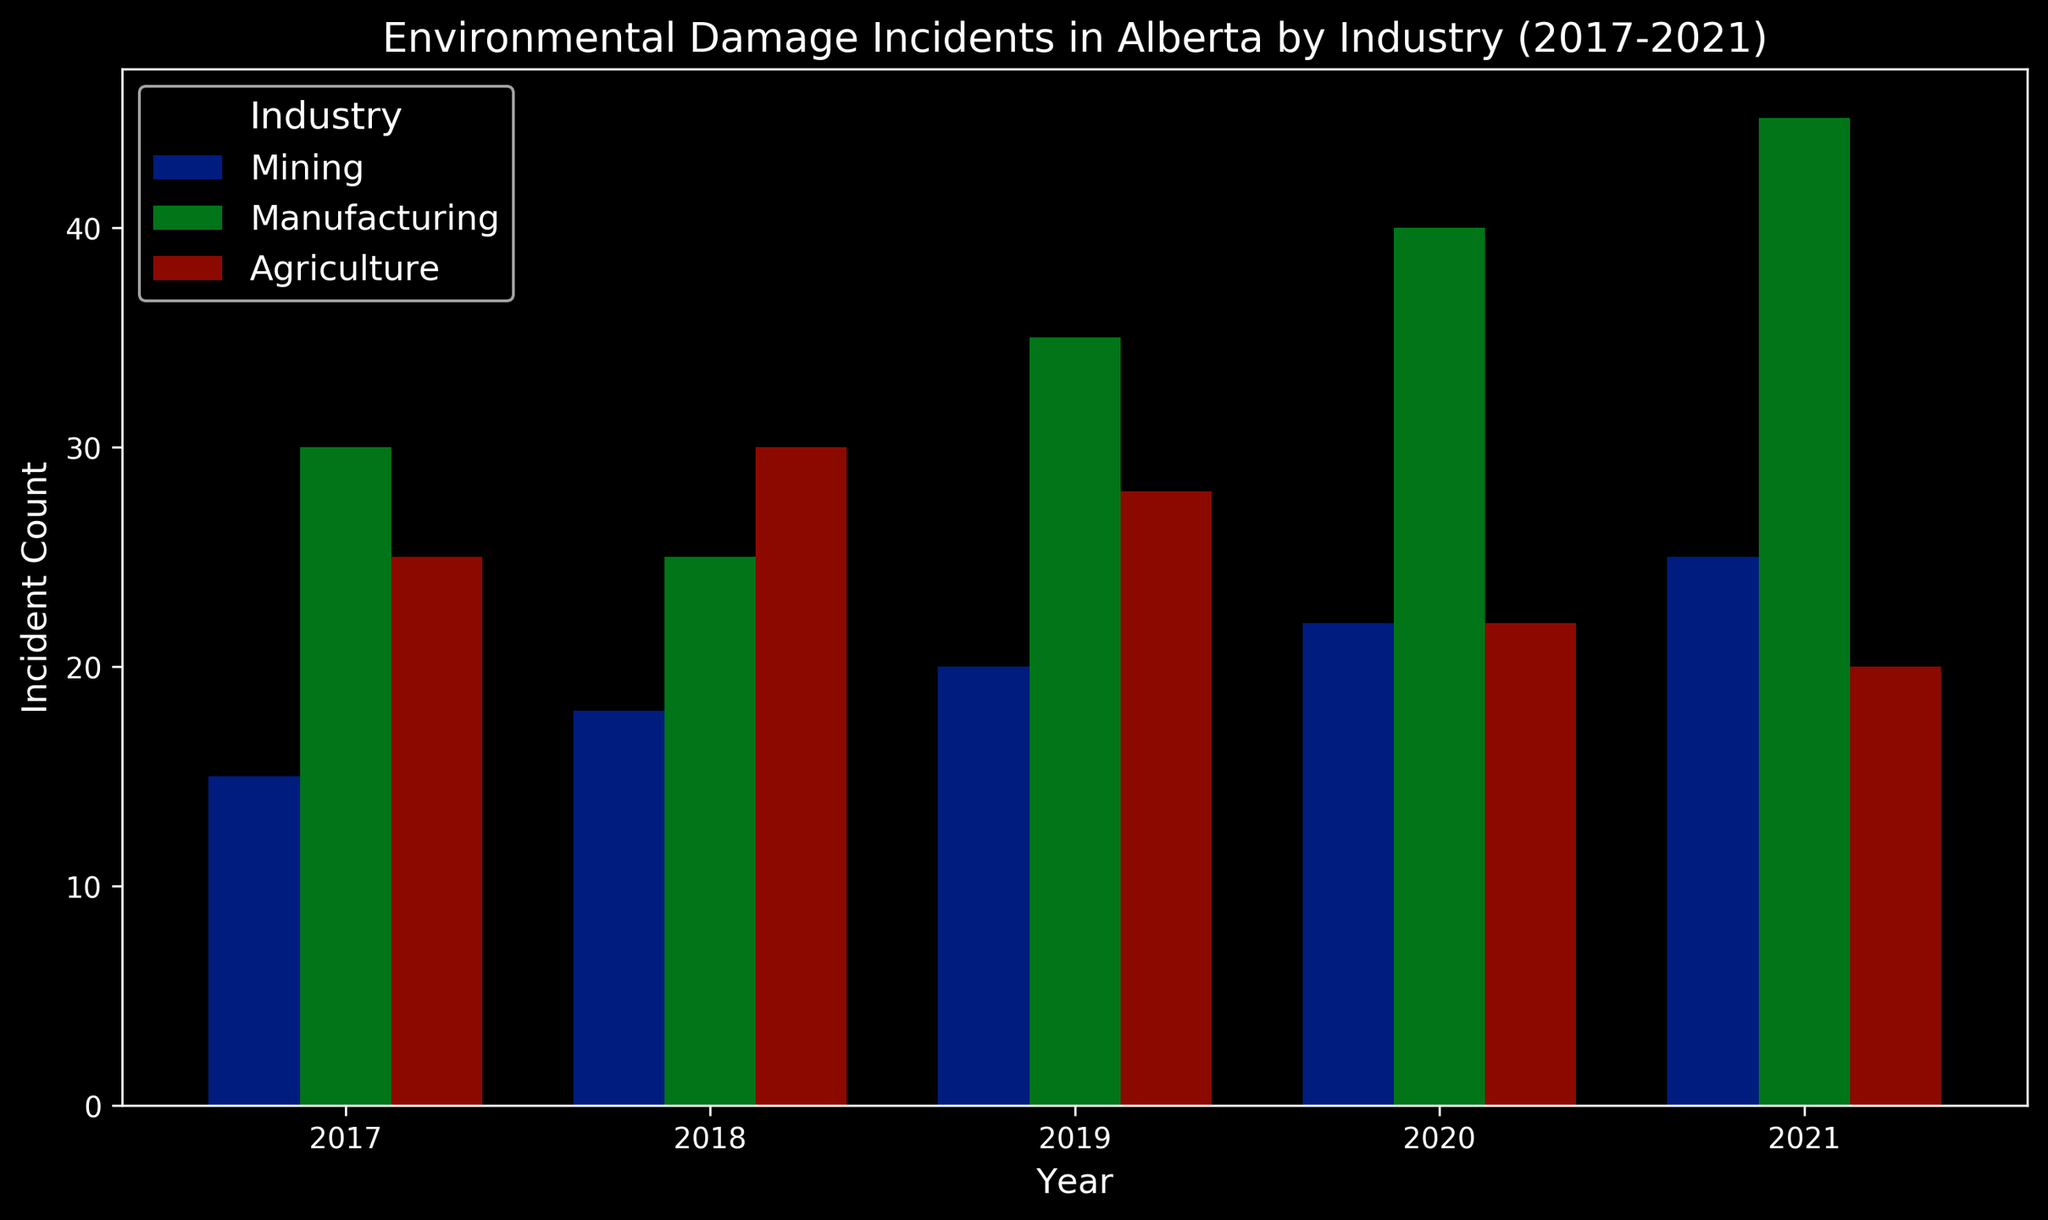What was the total number of environmental incidents in 2019? Sum up the incidents from mining, manufacturing, and agriculture in 2019: 20 (mining) + 35 (manufacturing) + 28 (agriculture) = 83
Answer: 83 Which industry had the highest number of incidents in 2020? Compare the incident counts for each industry in 2020: Mining (22), Manufacturing (40), and Agriculture (22). The highest is Manufacturing with 40 incidents
Answer: Manufacturing How did the number of incidents in agriculture change from 2017 to 2021? Compare the incidents in agriculture in 2017 (25) and 2021 (20): 25 - 20 = 5. The number decreased by 5
Answer: Decreased by 5 In which year did manufacturing incidents increase the most compared to the previous year? Calculate the increase in each year: 2018-2017 (25-30 = -5), 2019-2018 (35-25 = 10), 2020-2019 (40-35 = 5), 2021-2020 (45-40 = 5). The highest increase is from 2018 to 2019
Answer: 2019 What is the average number of incidents in the mining industry over these years? Sum the incidents in the mining industry from 2017 to 2021 and divide by 5: (15 + 18 + 20 + 22 + 25) / 5 = 20
Answer: 20 Which industry showed the most consistent trend in the number of incidents over the years? Evaluate trends across years for each industry. Manufacturing shows a consistent increase, while mining and agriculture have more fluctuations
Answer: Manufacturing Compare the number of incidents in agriculture in 2018 and 2020. Which year had fewer incidents? Incidents in agriculture: 2018 (30), 2020 (22). 2020 has fewer incidents
Answer: 2020 How many more incidents were there in manufacturing than in mining in 2021? Incidents in manufacturing (45) - incidents in mining (25) = 20
Answer: 20 Which year had the least total number of incidents across all industries? Sum incidents for each year: 2017 (70), 2018 (73), 2019 (83), 2020 (84), 2021 (90). The least number is 70 in 2017
Answer: 2017 